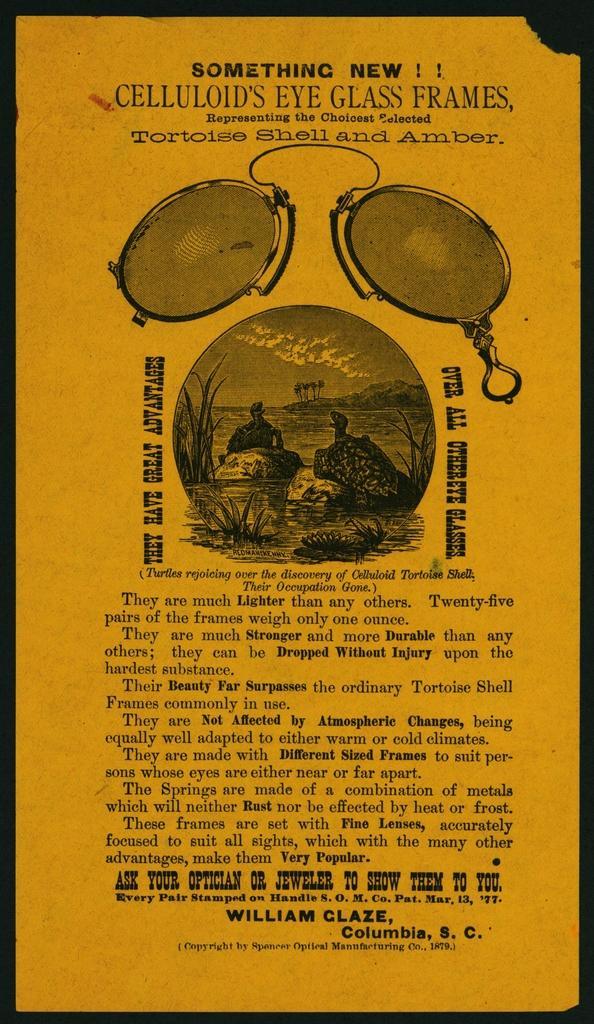What are the benefits of these eyeglass frames?
Your answer should be compact. Lighter, stronger, durable. What letters does the sign begin with?
Provide a short and direct response. S. 